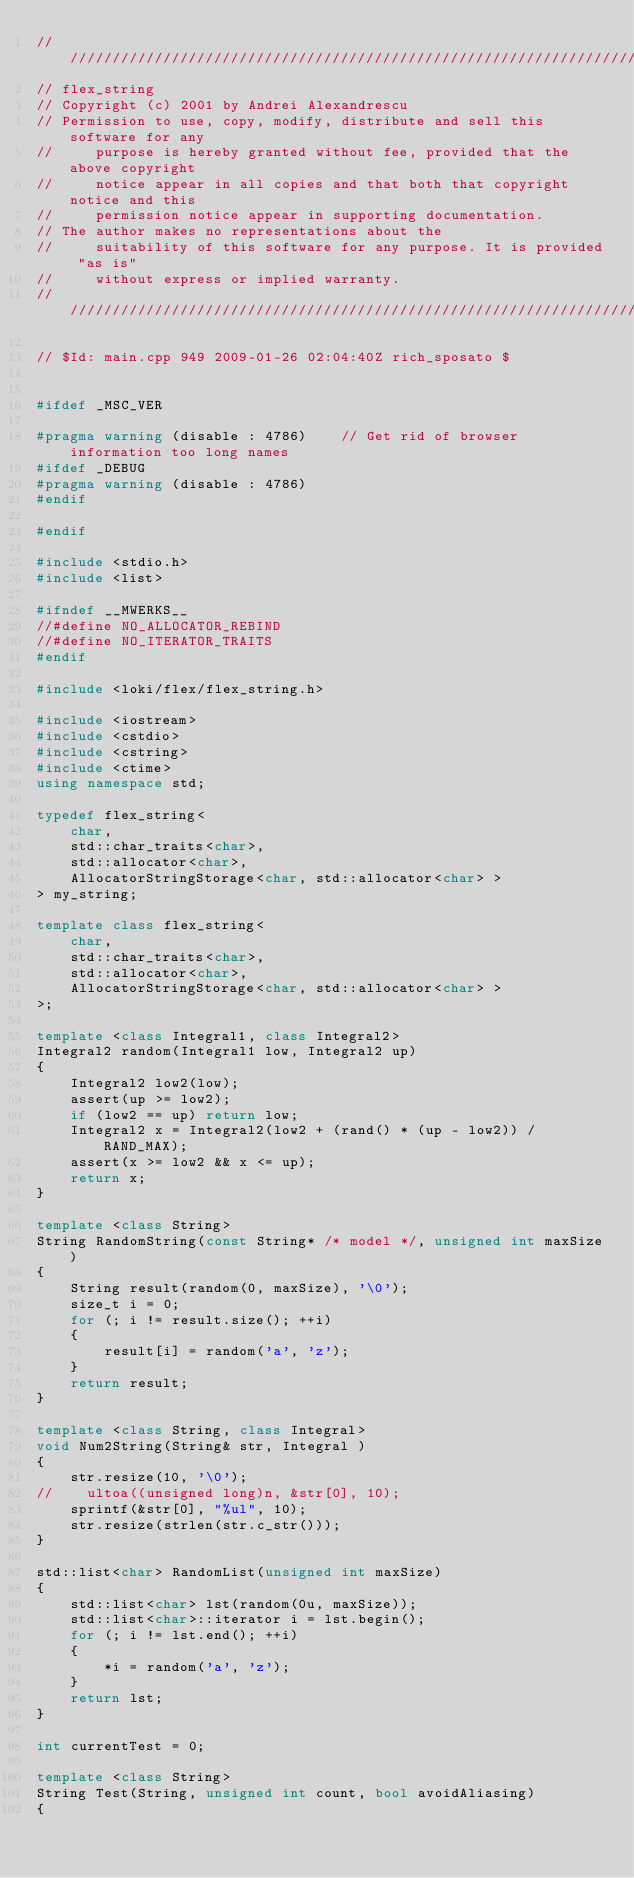Convert code to text. <code><loc_0><loc_0><loc_500><loc_500><_C++_>////////////////////////////////////////////////////////////////////////////////
// flex_string
// Copyright (c) 2001 by Andrei Alexandrescu
// Permission to use, copy, modify, distribute and sell this software for any
//     purpose is hereby granted without fee, provided that the above copyright
//     notice appear in all copies and that both that copyright notice and this
//     permission notice appear in supporting documentation.
// The author makes no representations about the
//     suitability of this software for any purpose. It is provided "as is"
//     without express or implied warranty.
////////////////////////////////////////////////////////////////////////////////

// $Id: main.cpp 949 2009-01-26 02:04:40Z rich_sposato $


#ifdef _MSC_VER

#pragma warning (disable : 4786)    // Get rid of browser information too long names
#ifdef _DEBUG
#pragma warning (disable : 4786)
#endif

#endif

#include <stdio.h>
#include <list>

#ifndef __MWERKS__
//#define NO_ALLOCATOR_REBIND
//#define NO_ITERATOR_TRAITS
#endif

#include <loki/flex/flex_string.h>

#include <iostream>
#include <cstdio>
#include <cstring>
#include <ctime>
using namespace std;  

typedef flex_string<
    char,
    std::char_traits<char>,
    std::allocator<char>,
    AllocatorStringStorage<char, std::allocator<char> >
> my_string;

template class flex_string<
    char,
    std::char_traits<char>,
    std::allocator<char>,
    AllocatorStringStorage<char, std::allocator<char> >
>;

template <class Integral1, class Integral2>
Integral2 random(Integral1 low, Integral2 up)
{
    Integral2 low2(low);
    assert(up >= low2);
    if (low2 == up) return low;
    Integral2 x = Integral2(low2 + (rand() * (up - low2)) / RAND_MAX);
    assert(x >= low2 && x <= up);
    return x;
}

template <class String>
String RandomString(const String* /* model */, unsigned int maxSize)
{
    String result(random(0, maxSize), '\0');
    size_t i = 0;
    for (; i != result.size(); ++i)
    {
        result[i] = random('a', 'z');
    }
    return result;
}

template <class String, class Integral>
void Num2String(String& str, Integral )
{
    str.resize(10, '\0');
//    ultoa((unsigned long)n, &str[0], 10);
    sprintf(&str[0], "%ul", 10);
    str.resize(strlen(str.c_str()));
}

std::list<char> RandomList(unsigned int maxSize)
{
    std::list<char> lst(random(0u, maxSize));
    std::list<char>::iterator i = lst.begin(); 
    for (; i != lst.end(); ++i)
    {
        *i = random('a', 'z');
    }
    return lst;
}

int currentTest = 0;

template <class String>
String Test(String, unsigned int count, bool avoidAliasing)
{</code> 